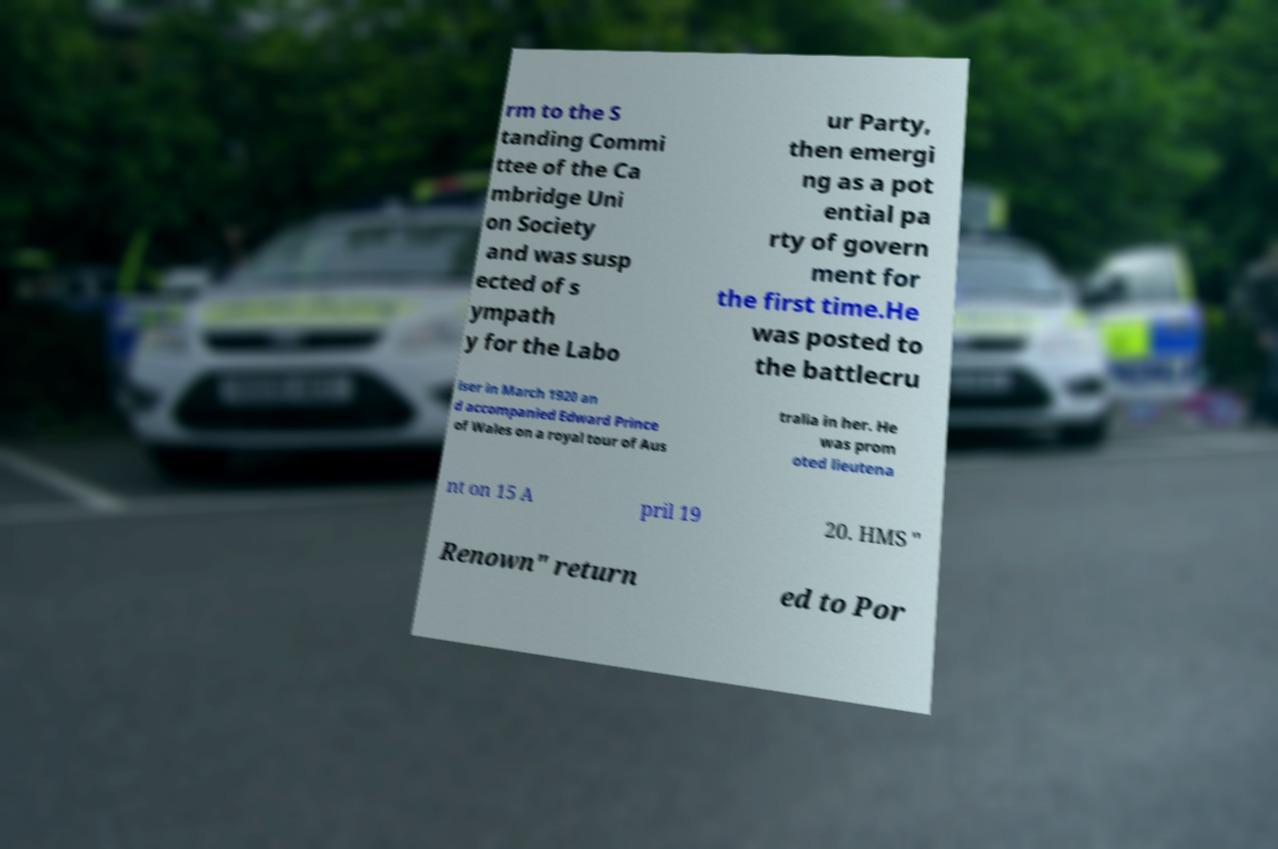For documentation purposes, I need the text within this image transcribed. Could you provide that? rm to the S tanding Commi ttee of the Ca mbridge Uni on Society and was susp ected of s ympath y for the Labo ur Party, then emergi ng as a pot ential pa rty of govern ment for the first time.He was posted to the battlecru iser in March 1920 an d accompanied Edward Prince of Wales on a royal tour of Aus tralia in her. He was prom oted lieutena nt on 15 A pril 19 20. HMS " Renown" return ed to Por 